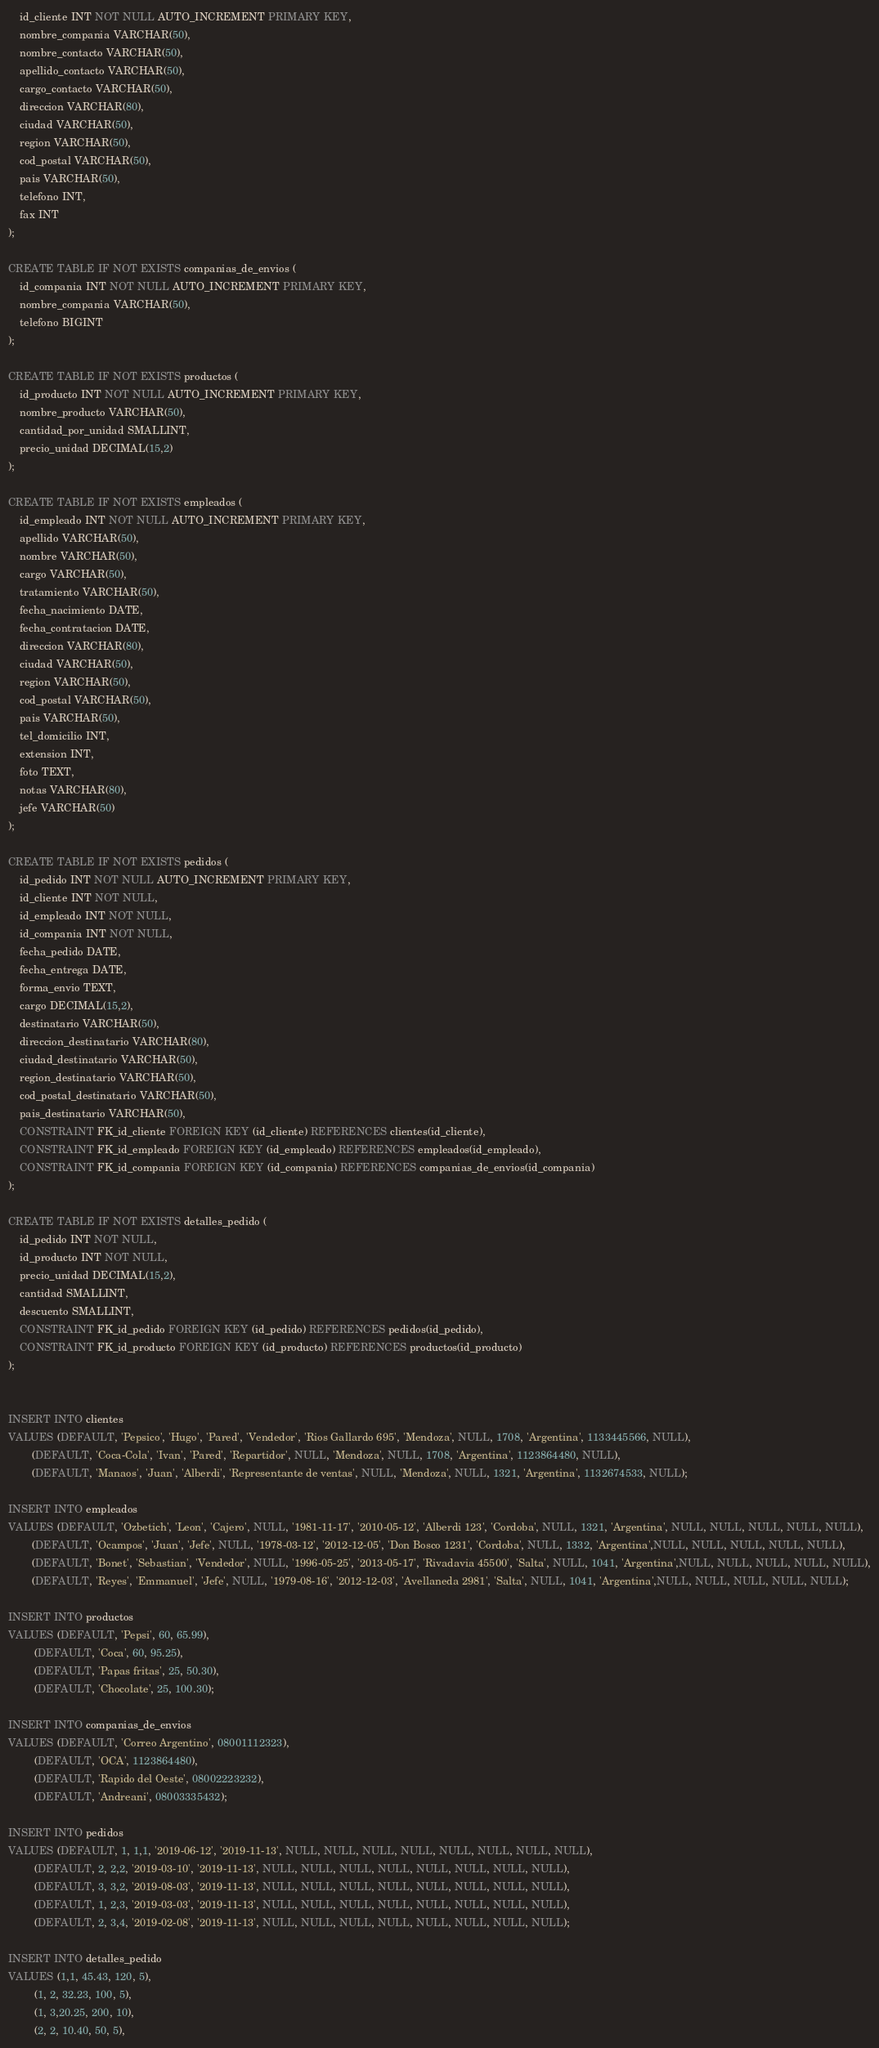<code> <loc_0><loc_0><loc_500><loc_500><_SQL_>	id_cliente INT NOT NULL AUTO_INCREMENT PRIMARY KEY,
	nombre_compania VARCHAR(50),
	nombre_contacto VARCHAR(50),
	apellido_contacto VARCHAR(50),
	cargo_contacto VARCHAR(50),
	direccion VARCHAR(80),
	ciudad VARCHAR(50),
	region VARCHAR(50),
	cod_postal VARCHAR(50),
	pais VARCHAR(50),
	telefono INT,
	fax INT
);

CREATE TABLE IF NOT EXISTS companias_de_envios (
	id_compania INT NOT NULL AUTO_INCREMENT PRIMARY KEY,
	nombre_compania VARCHAR(50),
	telefono BIGINT
);

CREATE TABLE IF NOT EXISTS productos (
	id_producto INT NOT NULL AUTO_INCREMENT PRIMARY KEY,
	nombre_producto VARCHAR(50),
	cantidad_por_unidad SMALLINT,
	precio_unidad DECIMAL(15,2)
);

CREATE TABLE IF NOT EXISTS empleados (
	id_empleado INT NOT NULL AUTO_INCREMENT PRIMARY KEY,
	apellido VARCHAR(50),
	nombre VARCHAR(50),
	cargo VARCHAR(50),
	tratamiento VARCHAR(50),
	fecha_nacimiento DATE,
	fecha_contratacion DATE,
	direccion VARCHAR(80),
	ciudad VARCHAR(50),
	region VARCHAR(50),
	cod_postal VARCHAR(50),
	pais VARCHAR(50),
	tel_domicilio INT,
	extension INT,
	foto TEXT,
	notas VARCHAR(80),
	jefe VARCHAR(50)
);

CREATE TABLE IF NOT EXISTS pedidos (
	id_pedido INT NOT NULL AUTO_INCREMENT PRIMARY KEY,
	id_cliente INT NOT NULL,
	id_empleado INT NOT NULL,
	id_compania INT NOT NULL,
	fecha_pedido DATE,
	fecha_entrega DATE,
	forma_envio TEXT,
	cargo DECIMAL(15,2),
	destinatario VARCHAR(50),
	direccion_destinatario VARCHAR(80),
	ciudad_destinatario VARCHAR(50),
	region_destinatario VARCHAR(50),
	cod_postal_destinatario VARCHAR(50),
	pais_destinatario VARCHAR(50),
	CONSTRAINT FK_id_cliente FOREIGN KEY (id_cliente) REFERENCES clientes(id_cliente),
	CONSTRAINT FK_id_empleado FOREIGN KEY (id_empleado) REFERENCES empleados(id_empleado),
	CONSTRAINT FK_id_compania FOREIGN KEY (id_compania) REFERENCES companias_de_envios(id_compania)
);

CREATE TABLE IF NOT EXISTS detalles_pedido (
	id_pedido INT NOT NULL,
	id_producto INT NOT NULL,
	precio_unidad DECIMAL(15,2),
	cantidad SMALLINT,
	descuento SMALLINT,
	CONSTRAINT FK_id_pedido FOREIGN KEY (id_pedido) REFERENCES pedidos(id_pedido),
	CONSTRAINT FK_id_producto FOREIGN KEY (id_producto) REFERENCES productos(id_producto)
);

	
INSERT INTO clientes 
VALUES (DEFAULT, 'Pepsico', 'Hugo', 'Pared', 'Vendedor', 'Rios Gallardo 695', 'Mendoza', NULL, 1708, 'Argentina', 1133445566, NULL),
		(DEFAULT, 'Coca-Cola', 'Ivan', 'Pared', 'Repartidor', NULL, 'Mendoza', NULL, 1708, 'Argentina', 1123864480, NULL),
		(DEFAULT, 'Manaos', 'Juan', 'Alberdi', 'Representante de ventas', NULL, 'Mendoza', NULL, 1321, 'Argentina', 1132674533, NULL);
		
INSERT INTO empleados
VALUES (DEFAULT, 'Ozbetich', 'Leon', 'Cajero', NULL, '1981-11-17', '2010-05-12', 'Alberdi 123', 'Cordoba', NULL, 1321, 'Argentina', NULL, NULL, NULL, NULL, NULL),
		(DEFAULT, 'Ocampos', 'Juan', 'Jefe', NULL, '1978-03-12', '2012-12-05', 'Don Bosco 1231', 'Cordoba', NULL, 1332, 'Argentina',NULL, NULL, NULL, NULL, NULL),
		(DEFAULT, 'Bonet', 'Sebastian', 'Vendedor', NULL, '1996-05-25', '2013-05-17', 'Rivadavia 45500', 'Salta', NULL, 1041, 'Argentina',NULL, NULL, NULL, NULL, NULL),
		(DEFAULT, 'Reyes', 'Emmanuel', 'Jefe', NULL, '1979-08-16', '2012-12-03', 'Avellaneda 2981', 'Salta', NULL, 1041, 'Argentina',NULL, NULL, NULL, NULL, NULL);

INSERT INTO productos
VALUES (DEFAULT, 'Pepsi', 60, 65.99),
		 (DEFAULT, 'Coca', 60, 95.25),
		 (DEFAULT, 'Papas fritas', 25, 50.30),
		 (DEFAULT, 'Chocolate', 25, 100.30);
		 
INSERT INTO companias_de_envios 
VALUES (DEFAULT, 'Correo Argentino', 08001112323),
		 (DEFAULT, 'OCA', 1123864480),
		 (DEFAULT, 'Rapido del Oeste', 08002223232),
		 (DEFAULT, 'Andreani', 08003335432);

INSERT INTO pedidos
VALUES (DEFAULT, 1, 1,1, '2019-06-12', '2019-11-13', NULL, NULL, NULL, NULL, NULL, NULL, NULL, NULL),
		 (DEFAULT, 2, 2,2, '2019-03-10', '2019-11-13', NULL, NULL, NULL, NULL, NULL, NULL, NULL, NULL),
		 (DEFAULT, 3, 3,2, '2019-08-03', '2019-11-13', NULL, NULL, NULL, NULL, NULL, NULL, NULL, NULL),
		 (DEFAULT, 1, 2,3, '2019-03-03', '2019-11-13', NULL, NULL, NULL, NULL, NULL, NULL, NULL, NULL),
		 (DEFAULT, 2, 3,4, '2019-02-08', '2019-11-13', NULL, NULL, NULL, NULL, NULL, NULL, NULL, NULL);

INSERT INTO detalles_pedido
VALUES (1,1, 45.43, 120, 5),
		 (1, 2, 32.23, 100, 5),
		 (1, 3,20.25, 200, 10),
		 (2, 2, 10.40, 50, 5),</code> 